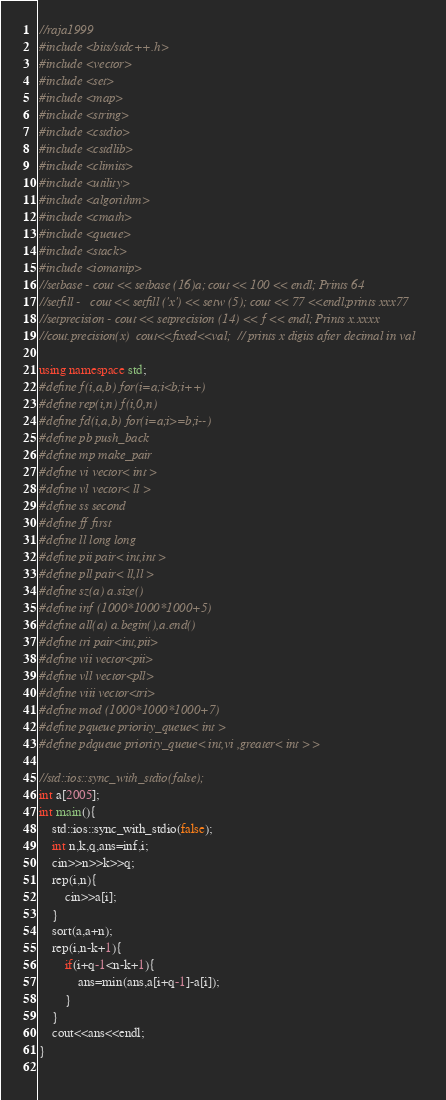Convert code to text. <code><loc_0><loc_0><loc_500><loc_500><_C++_>//raja1999
#include <bits/stdc++.h>
#include <vector>
#include <set>
#include <map>
#include <string>
#include <cstdio>
#include <cstdlib>
#include <climits>
#include <utility>
#include <algorithm>
#include <cmath>
#include <queue>
#include <stack>
#include <iomanip> 
//setbase - cout << setbase (16)a; cout << 100 << endl; Prints 64
//setfill -   cout << setfill ('x') << setw (5); cout << 77 <<endl;prints xxx77
//setprecision - cout << setprecision (14) << f << endl; Prints x.xxxx
//cout.precision(x)  cout<<fixed<<val;  // prints x digits after decimal in val

using namespace std;
#define f(i,a,b) for(i=a;i<b;i++)
#define rep(i,n) f(i,0,n)
#define fd(i,a,b) for(i=a;i>=b;i--)
#define pb push_back
#define mp make_pair
#define vi vector< int >
#define vl vector< ll >
#define ss second
#define ff first
#define ll long long
#define pii pair< int,int >
#define pll pair< ll,ll >
#define sz(a) a.size()
#define inf (1000*1000*1000+5)
#define all(a) a.begin(),a.end()
#define tri pair<int,pii>
#define vii vector<pii>
#define vll vector<pll>
#define viii vector<tri>
#define mod (1000*1000*1000+7)
#define pqueue priority_queue< int >
#define pdqueue priority_queue< int,vi ,greater< int > >

//std::ios::sync_with_stdio(false);
int a[2005];
int main(){
	std::ios::sync_with_stdio(false);
	int n,k,q,ans=inf,i;
	cin>>n>>k>>q;
	rep(i,n){
		cin>>a[i];
	} 
	sort(a,a+n);
	rep(i,n-k+1){
		if(i+q-1<n-k+1){
			ans=min(ans,a[i+q-1]-a[i]);
		}
	}	
	cout<<ans<<endl;
} 
	</code> 